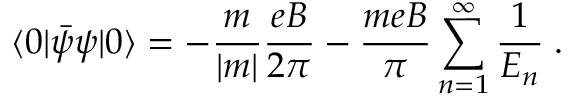Convert formula to latex. <formula><loc_0><loc_0><loc_500><loc_500>\langle 0 | { \bar { \psi } } \psi | 0 \rangle = - \frac { m } { | m | } \frac { e B } { 2 \pi } - \frac { m e B } { \pi } \sum _ { n = 1 } ^ { \infty } \frac { 1 } { E _ { n } } \, .</formula> 